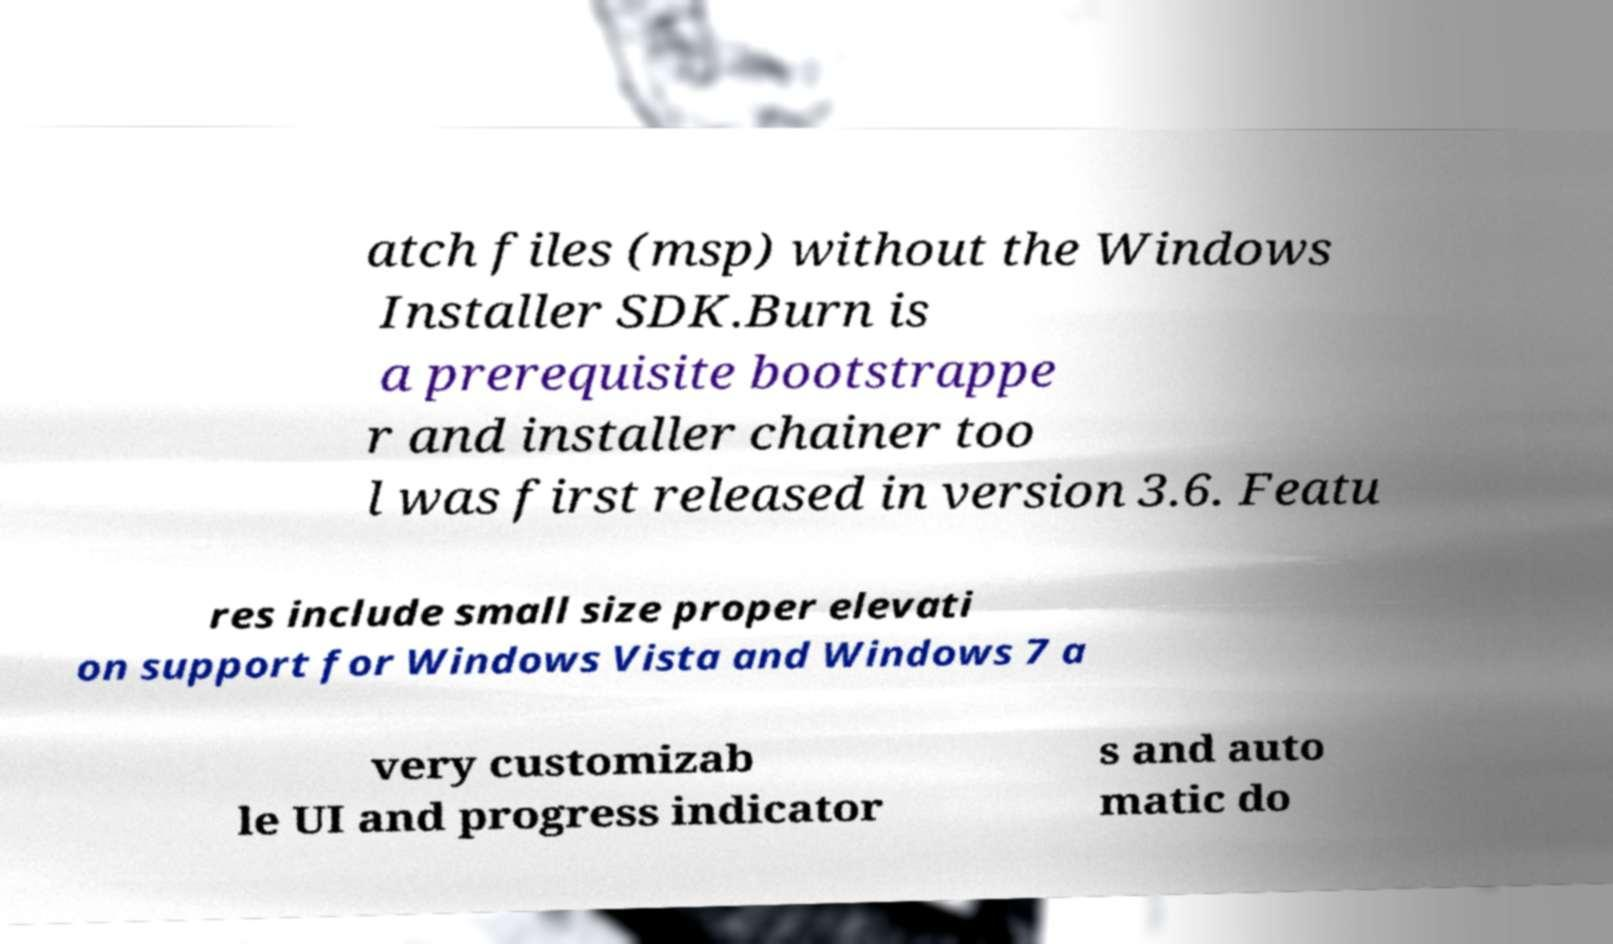Could you extract and type out the text from this image? atch files (msp) without the Windows Installer SDK.Burn is a prerequisite bootstrappe r and installer chainer too l was first released in version 3.6. Featu res include small size proper elevati on support for Windows Vista and Windows 7 a very customizab le UI and progress indicator s and auto matic do 